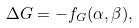<formula> <loc_0><loc_0><loc_500><loc_500>\Delta G = - f _ { G } ( \alpha , \beta ) ,</formula> 